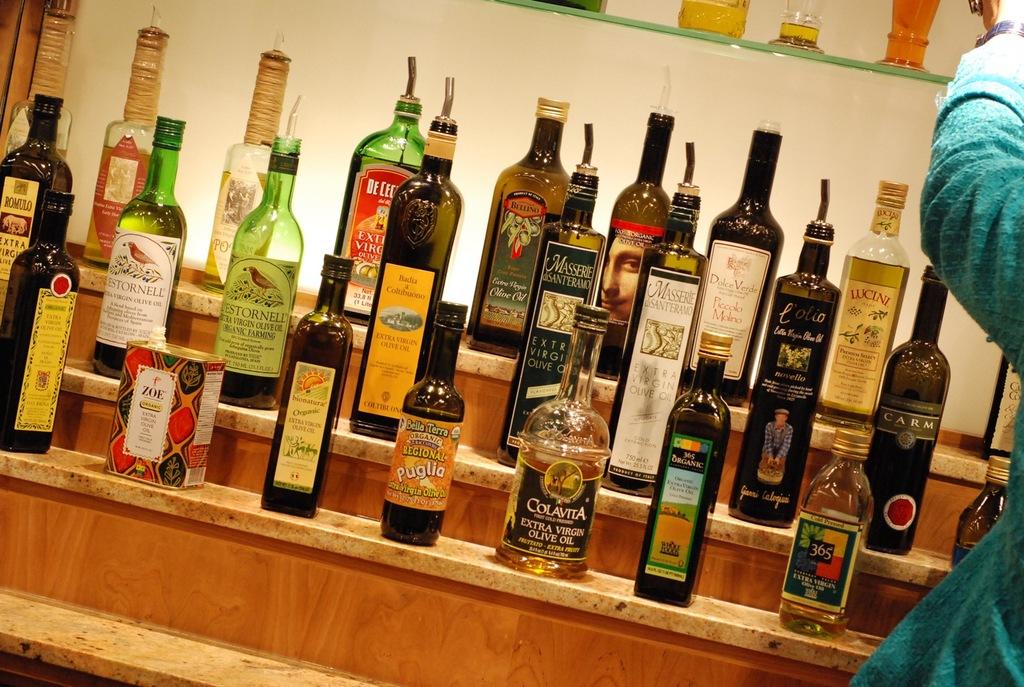What type of liquid is in all of these bottles?
Provide a short and direct response. Olive oil. 